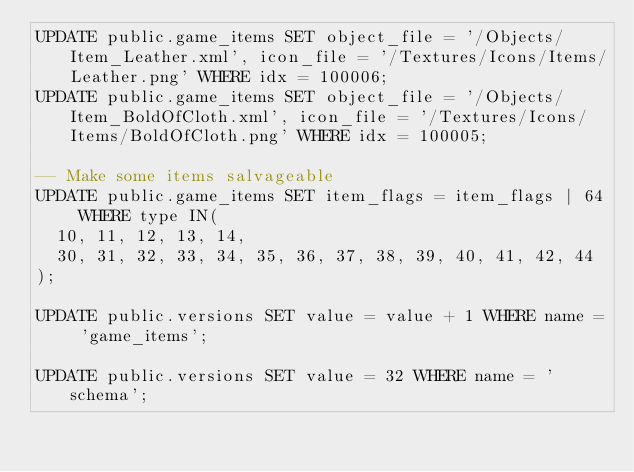Convert code to text. <code><loc_0><loc_0><loc_500><loc_500><_SQL_>UPDATE public.game_items SET object_file = '/Objects/Item_Leather.xml', icon_file = '/Textures/Icons/Items/Leather.png' WHERE idx = 100006;
UPDATE public.game_items SET object_file = '/Objects/Item_BoldOfCloth.xml', icon_file = '/Textures/Icons/Items/BoldOfCloth.png' WHERE idx = 100005;

-- Make some items salvageable
UPDATE public.game_items SET item_flags = item_flags | 64 WHERE type IN(
  10, 11, 12, 13, 14,
  30, 31, 32, 33, 34, 35, 36, 37, 38, 39, 40, 41, 42, 44
);

UPDATE public.versions SET value = value + 1 WHERE name = 'game_items';

UPDATE public.versions SET value = 32 WHERE name = 'schema';
</code> 